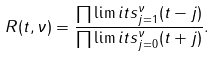Convert formula to latex. <formula><loc_0><loc_0><loc_500><loc_500>R ( t , \nu ) = \frac { \prod \lim i t s _ { j = 1 } ^ { \nu } ( t - j ) } { \prod \lim i t s _ { j = 0 } ^ { \nu } ( t + j ) } .</formula> 